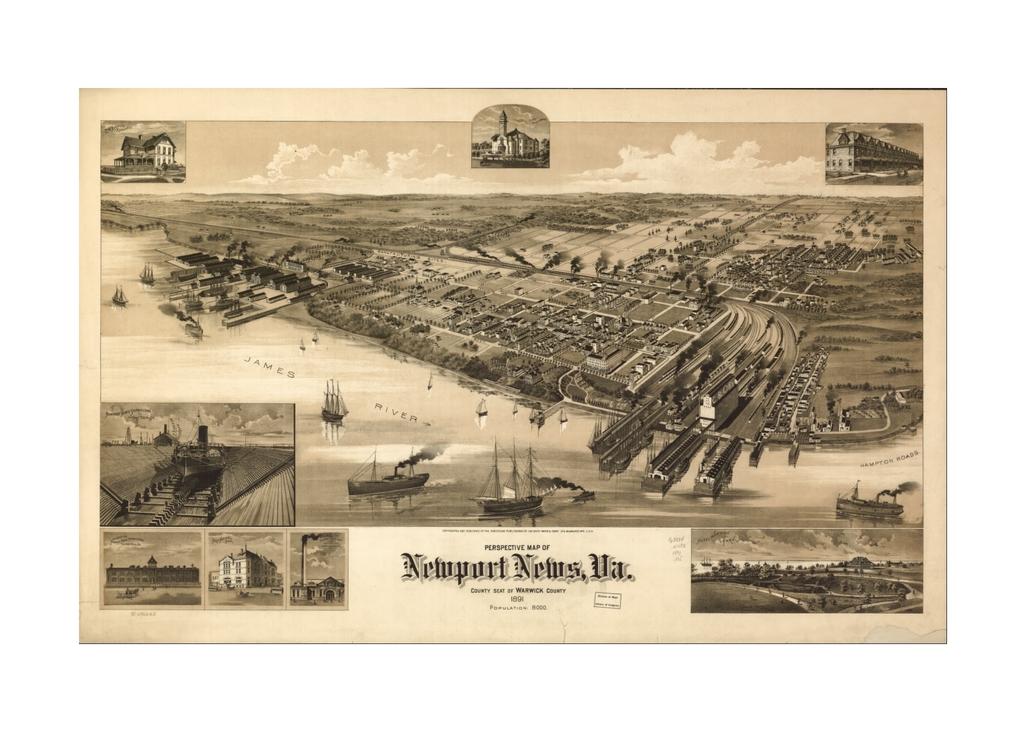What city is this?
Make the answer very short. Newport. What is the river in this drawing?
Keep it short and to the point. James river. 